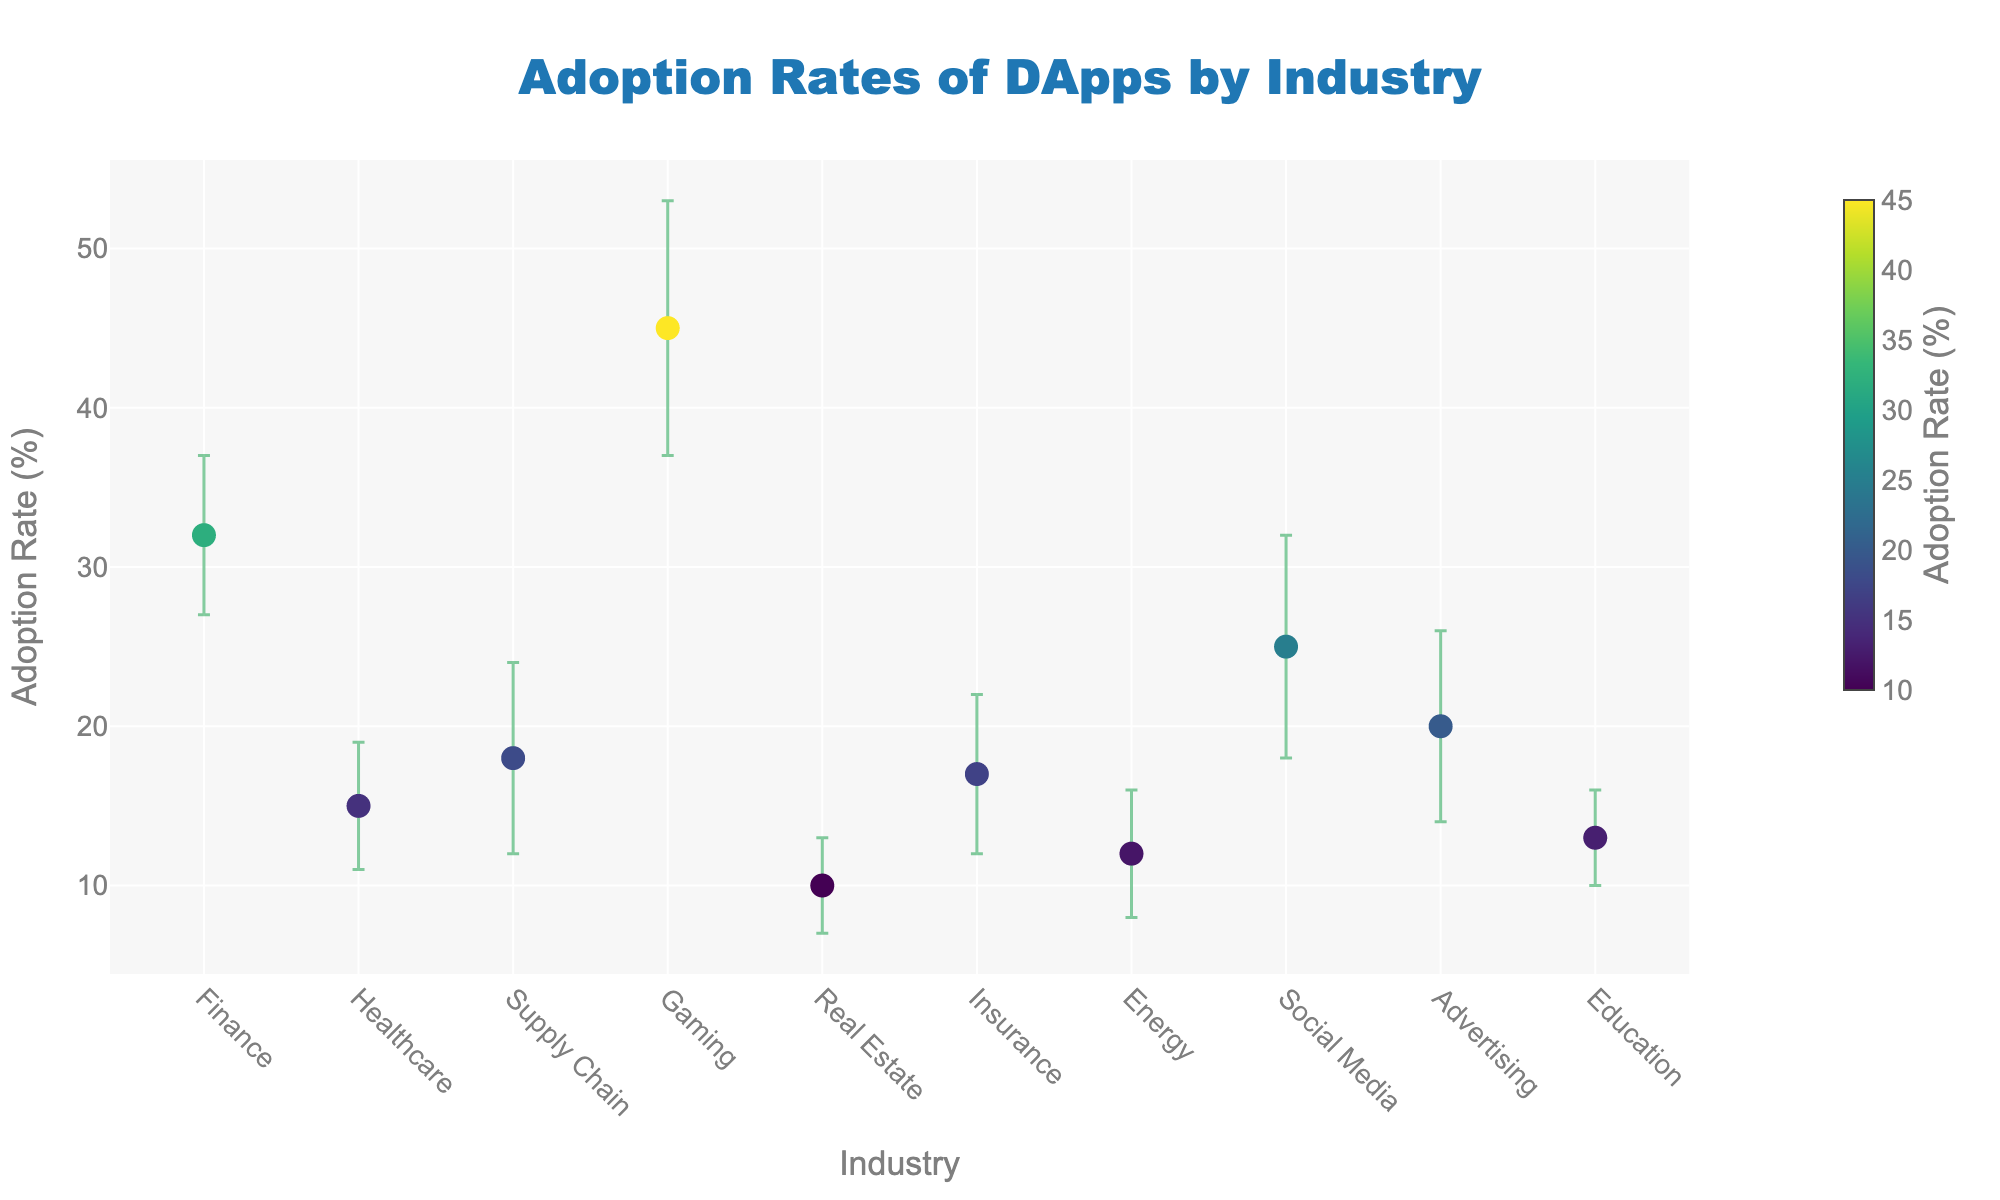What's the title of the figure? The title is the text at the top center of the figure, which reads "Adoption Rates of DApps by Industry".
Answer: Adoption Rates of DApps by Industry Which industry has the highest adoption rate of DApps? Look for the industry with the highest point on the vertical axis representing adoption rates. In this figure, the "Gaming" industry is at the top.
Answer: Gaming What is the adoption rate of DApps in the healthcare industry? Find the point labeled "Healthcare" on the x-axis and read the vertical position where the point is located, which is at 15%.
Answer: 15% Which industry has the smallest standard deviation in adoption rates, and what is its value? The size of error bars represents the standard deviation. The shortest error bar is for the "Real Estate" industry, and its value is 3%.
Answer: Real Estate, 3% Compare the adoption rates of Finance and Social Media. Which has a higher rate, and by how much? Locate both points on the x-axis: Finance is at 32% and Social Media is at 25%. Calculate the difference: 32% - 25% = 7%. So, Finance has a higher rate by 7%.
Answer: Finance, by 7% What is the average adoption rate of DApps across all industries? Sum the adoption rates of all industries and divide by the number of industries. (32 + 15 + 18 + 45 + 10 + 17 + 12 + 25 + 20 + 13) / 10 = 207 / 10 = 20.7%.
Answer: 20.7% List the industries with an adoption rate above 20%. Identify the points above the 20% mark on the y-axis and list their labels: Finance, Gaming, and Social Media.
Answer: Finance, Gaming, Social Media What is the range of adoption rates for the industries shown? The range is the difference between the highest and lowest adoption rates. The highest rate is 45% (Gaming) and the lowest is 10% (Real Estate), so the range is 45% - 10% = 35%.
Answer: 35% Which industry has both the lowest adoption rate and the smallest standard deviation? Look for the industry with the lowest point on the y-axis having the smallest error bar width. Real Estate has the lowest rate at 10% and the smallest standard deviation of 3%.
Answer: Real Estate Is there any industry with an adoption rate close to the average rate and within one standard deviation of the mean? The average adoption rate is 20.7%. Check the points around this value and their error bars. The "Advertising" industry has an adoption rate of 20% and a standard deviation of 6%, which includes the average (20.7%) within one standard deviation.
Answer: Advertising 